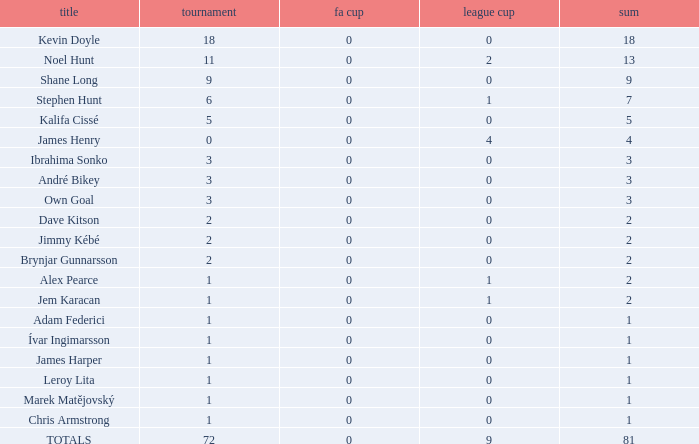What is the complete count of championships james henry has with over one league cup? 0.0. 